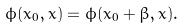Convert formula to latex. <formula><loc_0><loc_0><loc_500><loc_500>\phi ( x _ { 0 } , { x } ) = \phi ( x _ { 0 } + \beta , { x } ) .</formula> 